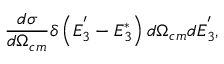Convert formula to latex. <formula><loc_0><loc_0><loc_500><loc_500>\frac { d \sigma } { d \Omega _ { c m } } \delta \left ( E _ { 3 } ^ { ^ { \prime } } - E _ { 3 } ^ { * } \right ) d \Omega _ { c m } d E _ { 3 } ^ { ^ { \prime } } ,</formula> 